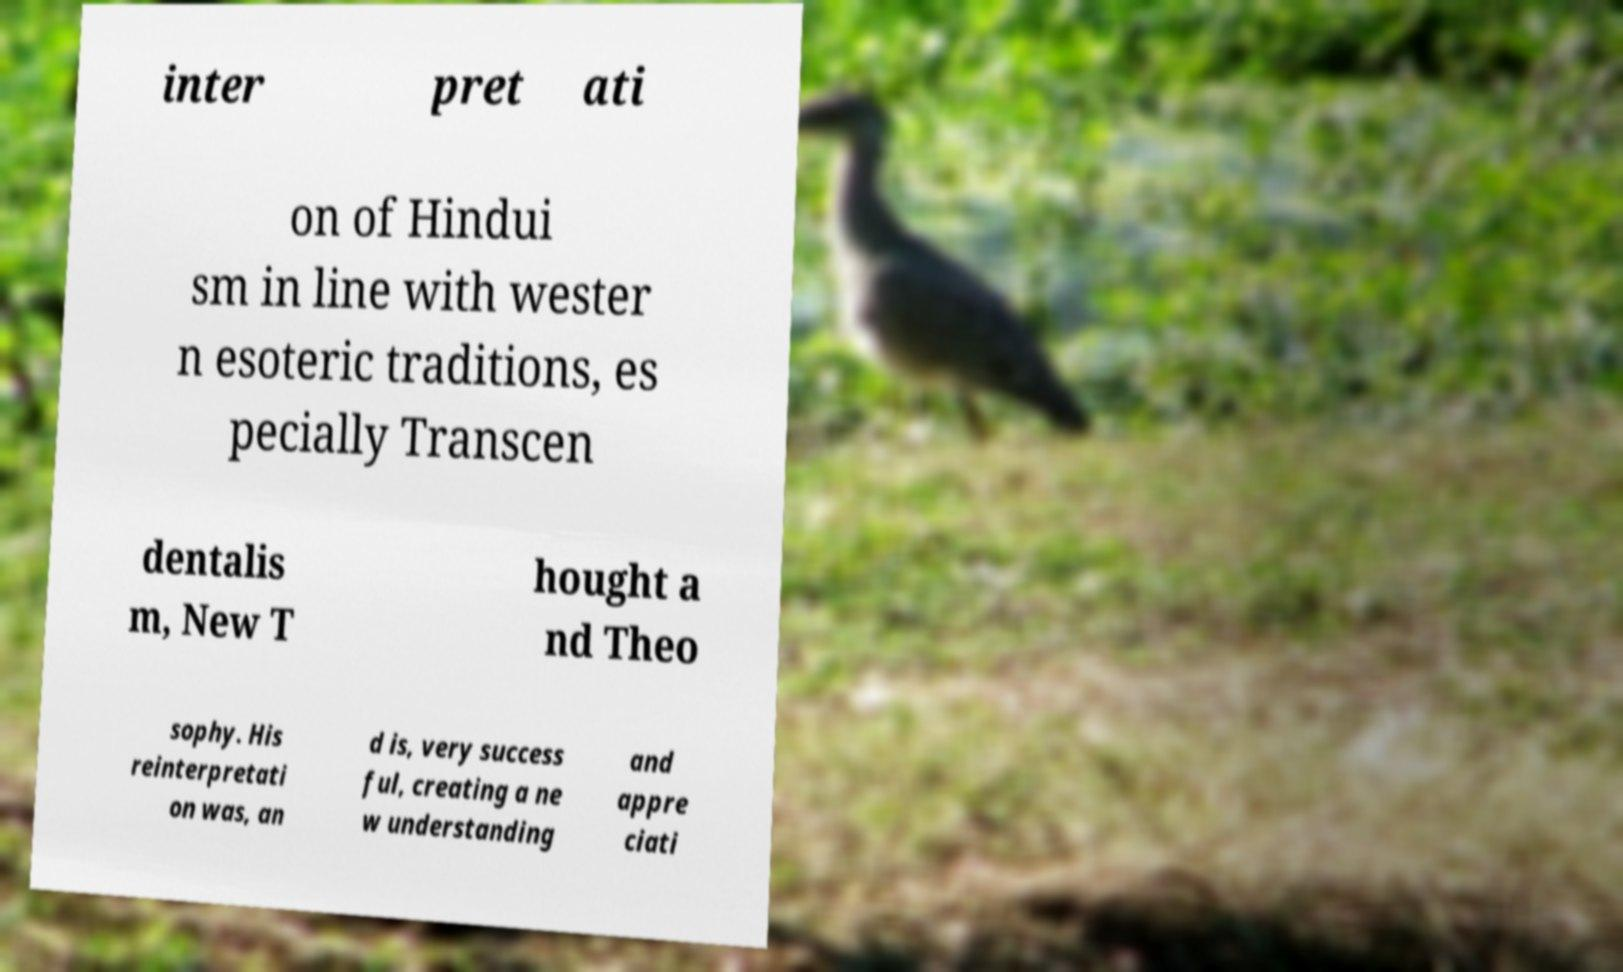Can you accurately transcribe the text from the provided image for me? inter pret ati on of Hindui sm in line with wester n esoteric traditions, es pecially Transcen dentalis m, New T hought a nd Theo sophy. His reinterpretati on was, an d is, very success ful, creating a ne w understanding and appre ciati 